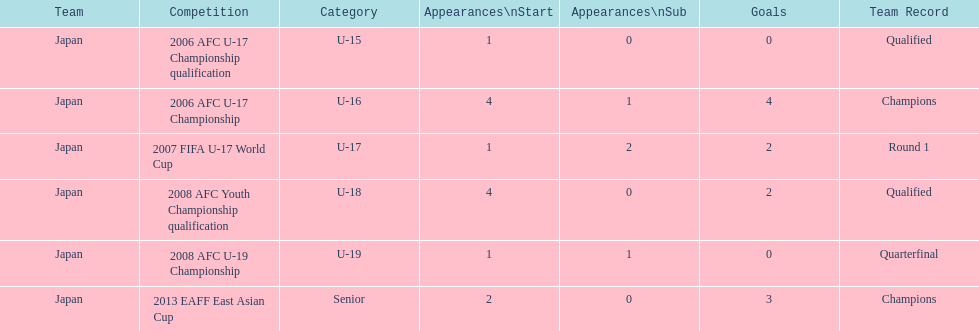In how many key competitions did yoichiro kakitani achieve over 2 goals? 2. 